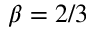<formula> <loc_0><loc_0><loc_500><loc_500>\beta = 2 / 3</formula> 